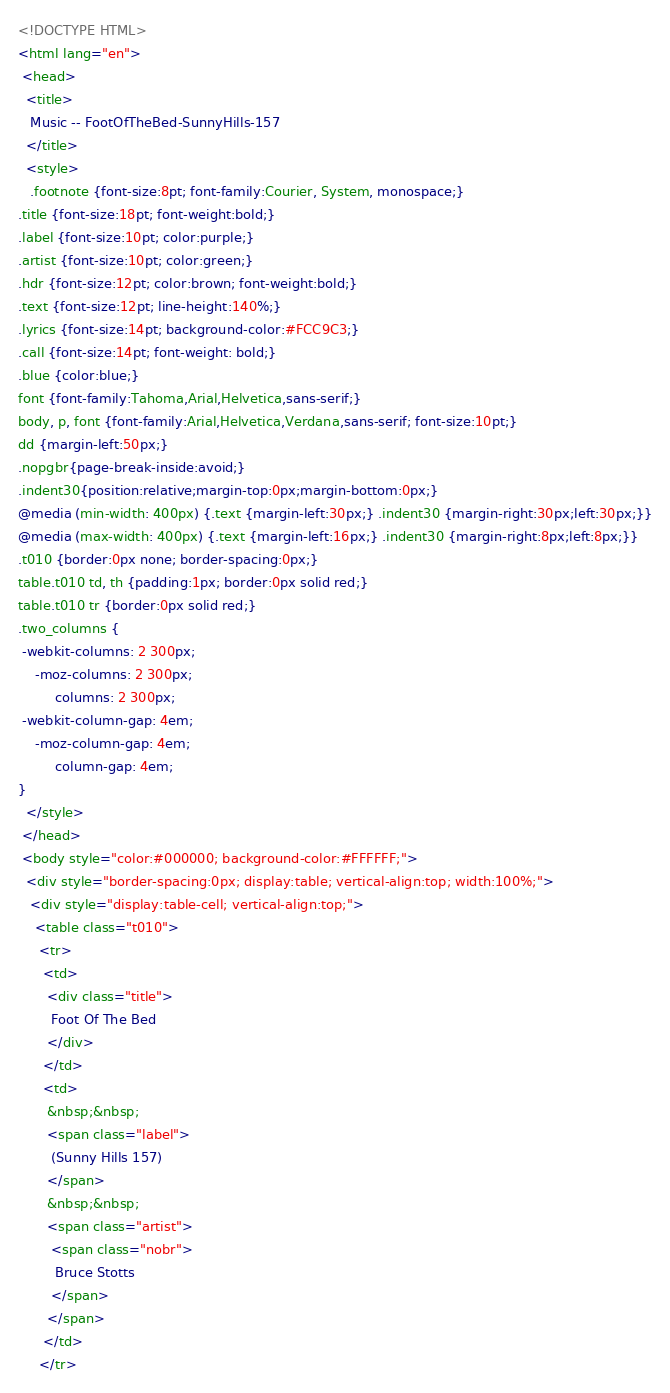Convert code to text. <code><loc_0><loc_0><loc_500><loc_500><_HTML_><!DOCTYPE HTML>
<html lang="en">
 <head>
  <title>
   Music -- FootOfTheBed-SunnyHills-157
  </title>
  <style>
   .footnote {font-size:8pt; font-family:Courier, System, monospace;}
.title {font-size:18pt; font-weight:bold;}
.label {font-size:10pt; color:purple;}
.artist {font-size:10pt; color:green;}
.hdr {font-size:12pt; color:brown; font-weight:bold;}
.text {font-size:12pt; line-height:140%;}
.lyrics {font-size:14pt; background-color:#FCC9C3;}
.call {font-size:14pt; font-weight: bold;}
.blue {color:blue;}
font {font-family:Tahoma,Arial,Helvetica,sans-serif;}
body, p, font {font-family:Arial,Helvetica,Verdana,sans-serif; font-size:10pt;}
dd {margin-left:50px;}
.nopgbr{page-break-inside:avoid;}
.indent30{position:relative;margin-top:0px;margin-bottom:0px;}
@media (min-width: 400px) {.text {margin-left:30px;} .indent30 {margin-right:30px;left:30px;}}
@media (max-width: 400px) {.text {margin-left:16px;} .indent30 {margin-right:8px;left:8px;}}
.t010 {border:0px none; border-spacing:0px;}
table.t010 td, th {padding:1px; border:0px solid red;}
table.t010 tr {border:0px solid red;}
.two_columns {
 -webkit-columns: 2 300px;
    -moz-columns: 2 300px;
         columns: 2 300px;
 -webkit-column-gap: 4em;
    -moz-column-gap: 4em;
         column-gap: 4em;
}
  </style>
 </head>
 <body style="color:#000000; background-color:#FFFFFF;">
  <div style="border-spacing:0px; display:table; vertical-align:top; width:100%;">
   <div style="display:table-cell; vertical-align:top;">
    <table class="t010">
     <tr>
      <td>
       <div class="title">
        Foot Of The Bed
       </div>
      </td>
      <td>
       &nbsp;&nbsp;
       <span class="label">
        (Sunny Hills 157)
       </span>
       &nbsp;&nbsp;
       <span class="artist">
        <span class="nobr">
         Bruce Stotts
        </span>
       </span>
      </td>
     </tr></code> 